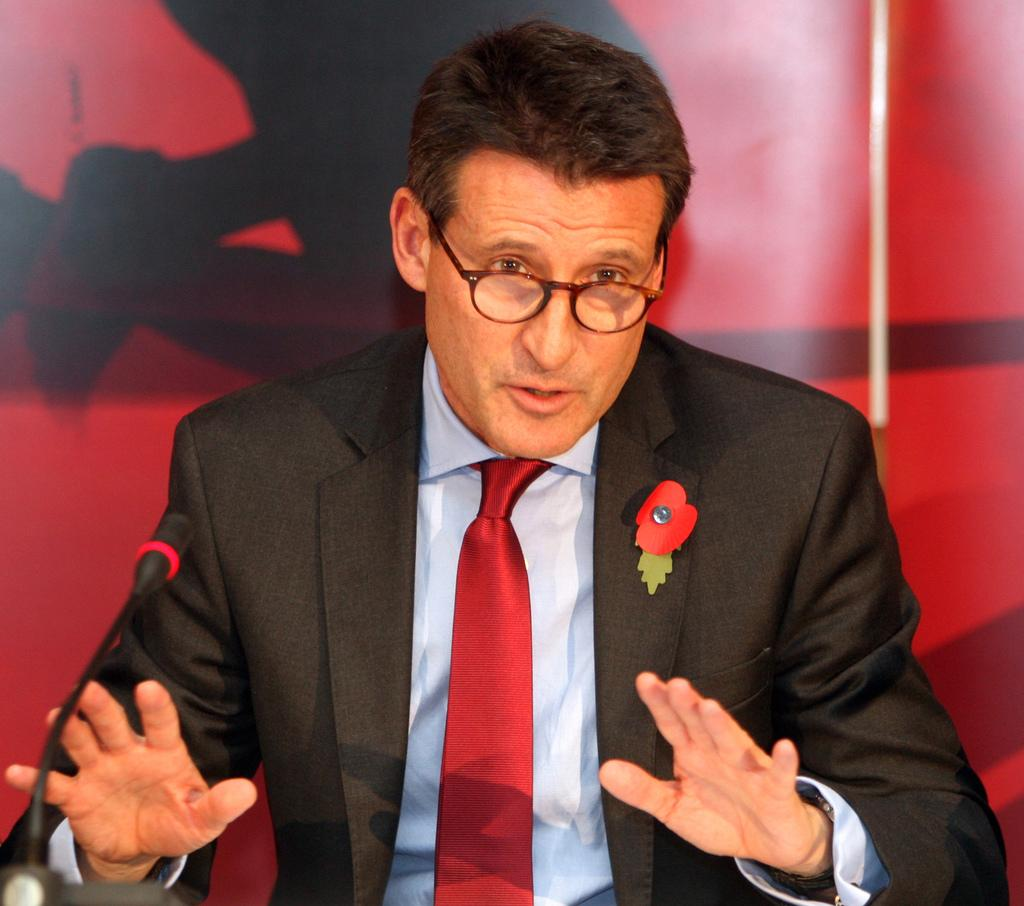What is the main subject of the image? There is a man in the image. What is the man wearing? The man is wearing a black suit and a red tie. What can be seen on the left side of the image? There is a mic on the left side of the image. What color is the poster on the wall in the background? There is a red color poster on the wall in the background. What type of honey is the man using to clear his throat in the image? There is no honey or indication of the man clearing his throat in the image. 